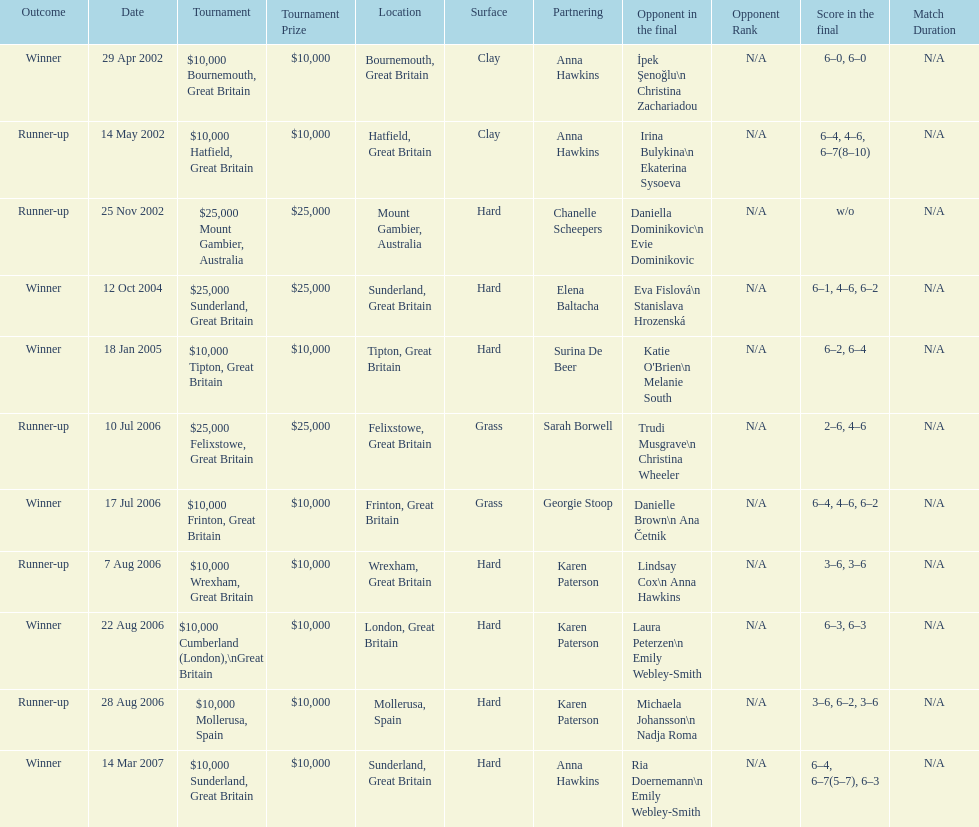How many surfaces are grass? 2. 